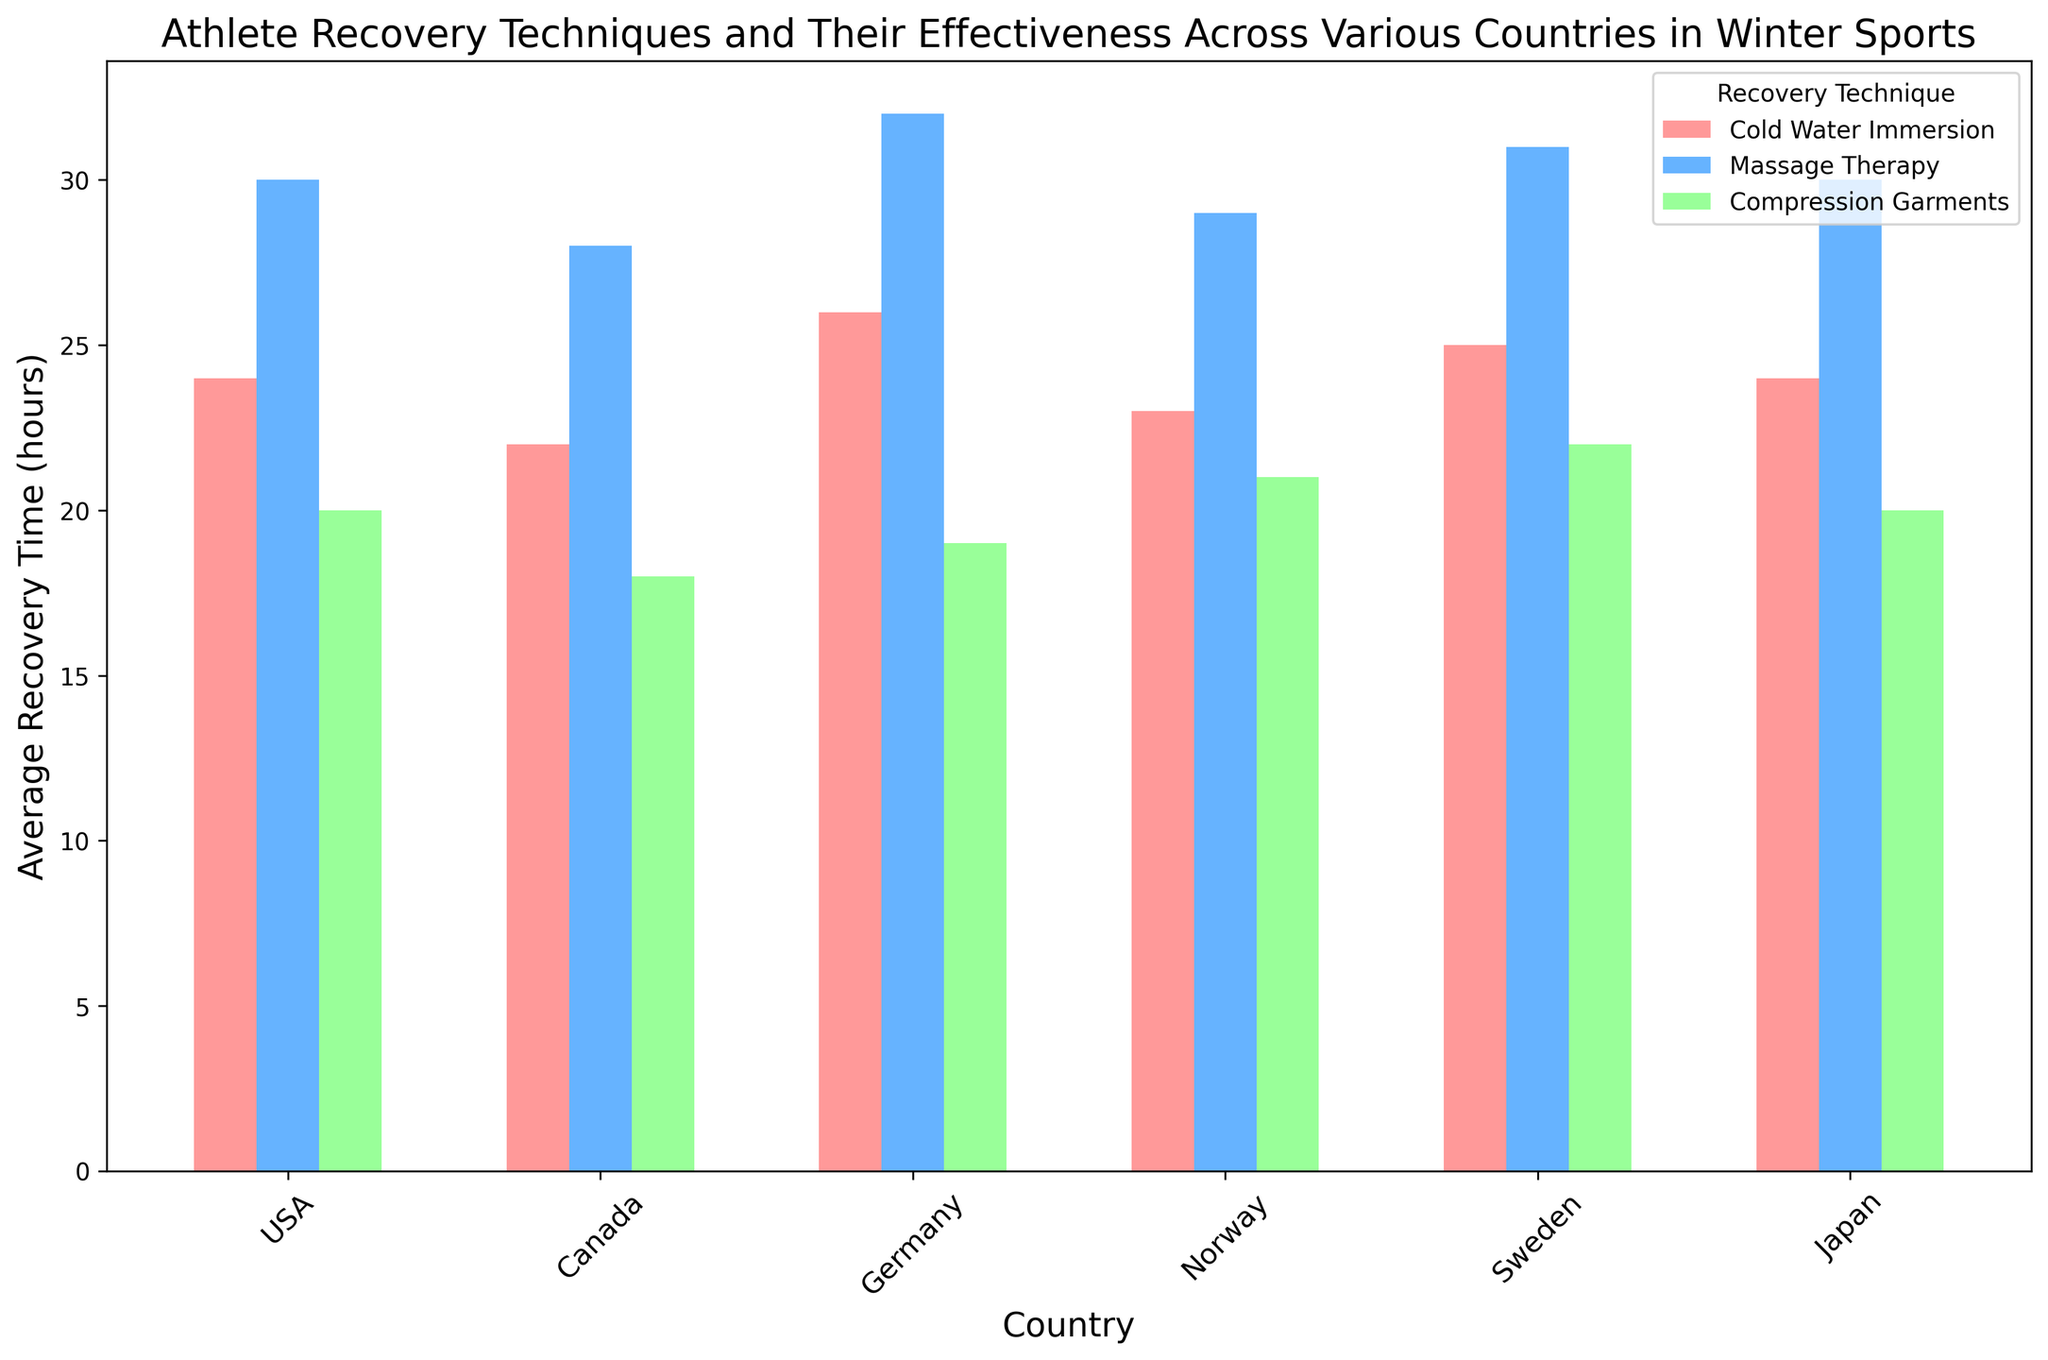What is the average recovery time for Compression Garments across all countries? To find the average recovery time for Compression Garments across all countries, add the individual recovery times for each country and divide by the number of countries: (20 + 18 + 19 + 21 + 22 + 20) / 6 =120 / 6 = 20
Answer: 20 Which country has the lowest average recovery time for Cold Water Immersion? Compare the average recovery times for Cold Water Immersion across all countries and identify the lowest. USA: 24, Canada: 22, Germany: 26, Norway: 23, Sweden: 25, Japan: 24. Canada has the lowest at 22.
Answer: Canada Among the techniques used in the USA, which one has the highest effectiveness rate? Compare the effectiveness rates of different techniques used in the USA. Cold Water Immersion: 78%, Massage Therapy: 85%, Compression Garments: 74%. Massage Therapy has the highest effectiveness rate.
Answer: Massage Therapy Compare the average recovery time between Massage Therapy in Canada and Norway. Which country has a lower average recovery time for this technique? Compare the average recovery time for Massage Therapy between Canada and Norway. Canada: 28 hours, Norway: 29 hours. Canada has a lower average recovery time.
Answer: Canada What is the difference in effectiveness rate between Cold Water Immersion and Compression Garments in Japan? Find the effectiveness rates for Cold Water Immersion (79%) and Compression Garments (75%) in Japan and calculate the difference: 79% - 75% = 4%
Answer: 4% Which technique shows the most consistent average recovery times across all countries? Evaluate and compare the fluctuation in recovery times for each technique across all countries. Compression Garments vary from 18 to 22. Cold Water Immersion varies from 22 to 26. Massage Therapy varies from 28 to 32. Compression Garments show the most consistent times.
Answer: Compression Garments By how many hours is the average recovery time for Compression Garments in Sweden greater than that in Canada? Compare the average recovery times for Compression Garments in Sweden (22 hours) and Canada (18 hours) and find the difference: 22 - 18 = 4 hours
Answer: 4 If the average recovery times for Massage Therapy in Germany and Cold Water Immersion in Japan are combined, what is the total? Sum the average recovery times for Massage Therapy in Germany (32 hours) and Cold Water Immersion in Japan (24 hours): 32 + 24 = 56
Answer: 56 What is the maximum effectiveness rate observed for any technique in Norway? Review the effectiveness rates for all techniques in Norway: Cold Water Immersion: 77%, Massage Therapy: 84%, Compression Garments: 73%. The maximum effectiveness rate is 84% for Massage Therapy.
Answer: 84 Which country has the highest variation in average recovery times among the three techniques? Evaluate and compare the range (maximum - minimum) of recovery times across all techniques for each country. USA: 30 - 20 = 10, Canada: 28 - 18 = 10, Germany: 32 - 19 = 13, Norway: 29 - 21 = 8, Sweden: 31 - 22 = 9, Japan: 30 - 20 = 10. Germany has the highest variation (13).
Answer: Germany 